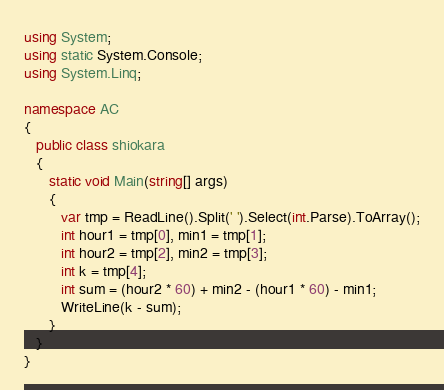<code> <loc_0><loc_0><loc_500><loc_500><_C#_>using System;
using static System.Console;
using System.Linq;

namespace AC
{
   public class shiokara
   {
      static void Main(string[] args)
      {
         var tmp = ReadLine().Split(' ').Select(int.Parse).ToArray();
         int hour1 = tmp[0], min1 = tmp[1];
         int hour2 = tmp[2], min2 = tmp[3];
         int k = tmp[4];
         int sum = (hour2 * 60) + min2 - (hour1 * 60) - min1;
         WriteLine(k - sum);
      }
   }
}</code> 